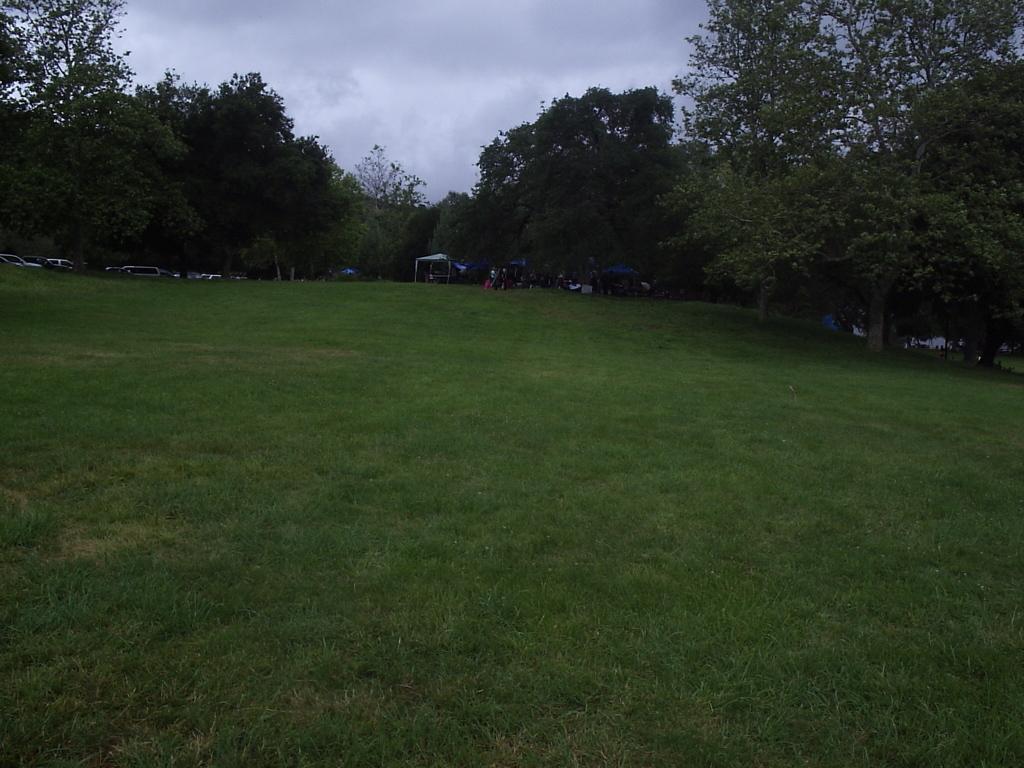Please provide a concise description of this image. In this image we can see grass on the ground. In the back there are trees. Also there are vehicles. And there is sky with clouds. 